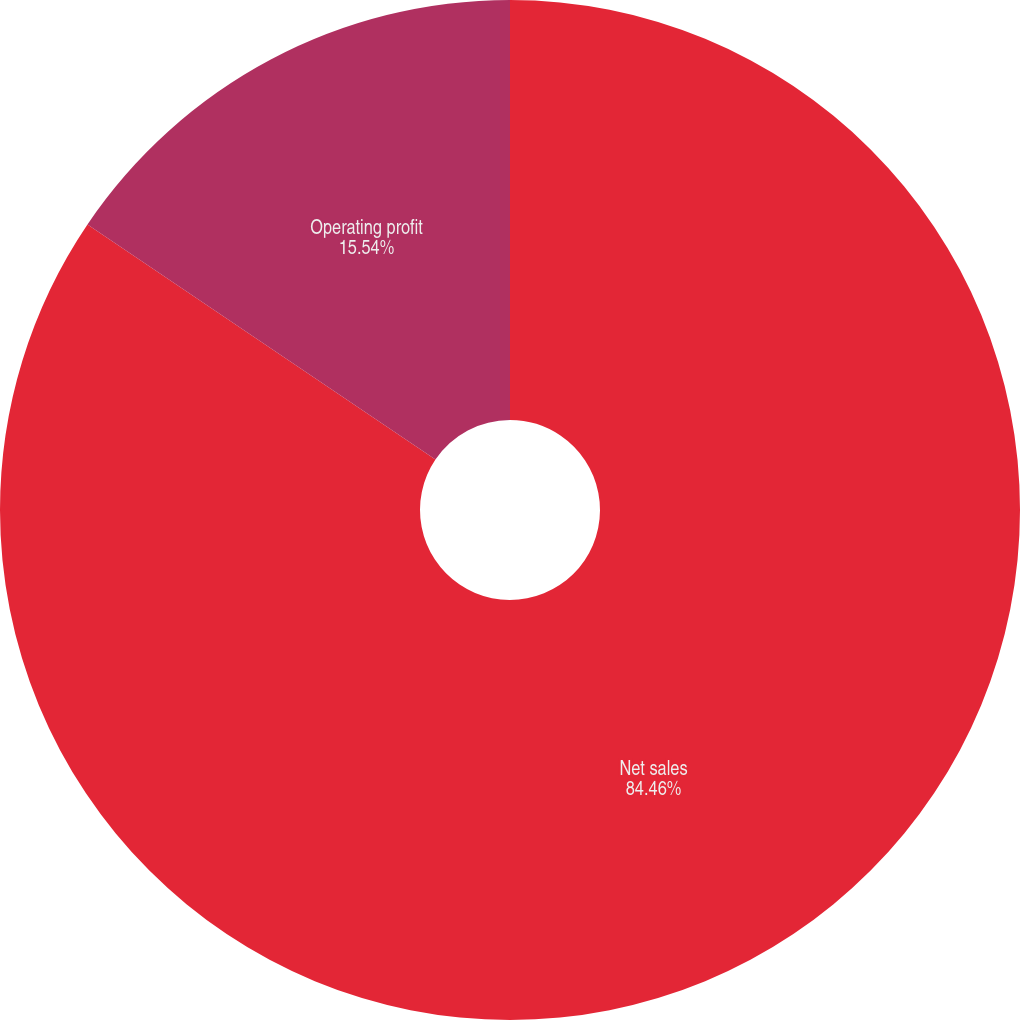Convert chart to OTSL. <chart><loc_0><loc_0><loc_500><loc_500><pie_chart><fcel>Net sales<fcel>Operating profit<nl><fcel>84.46%<fcel>15.54%<nl></chart> 